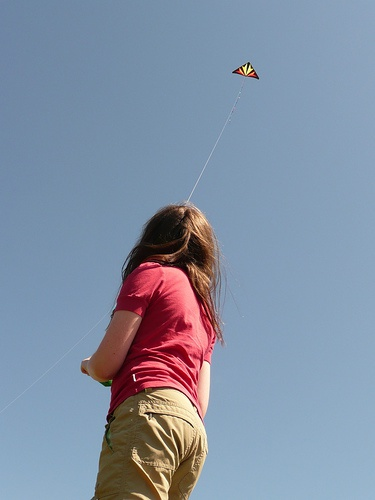Describe the objects in this image and their specific colors. I can see people in gray, maroon, black, and salmon tones and kite in gray, black, maroon, and khaki tones in this image. 